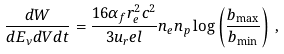Convert formula to latex. <formula><loc_0><loc_0><loc_500><loc_500>\frac { d W } { d E _ { \nu } d V d t } = \frac { 1 6 \alpha _ { f } r _ { e } ^ { 2 } c ^ { 2 } } { 3 u _ { r } e l } n _ { e } n _ { p } \log \left ( \frac { b _ { \max } } { b _ { \min } } \right ) \, ,</formula> 